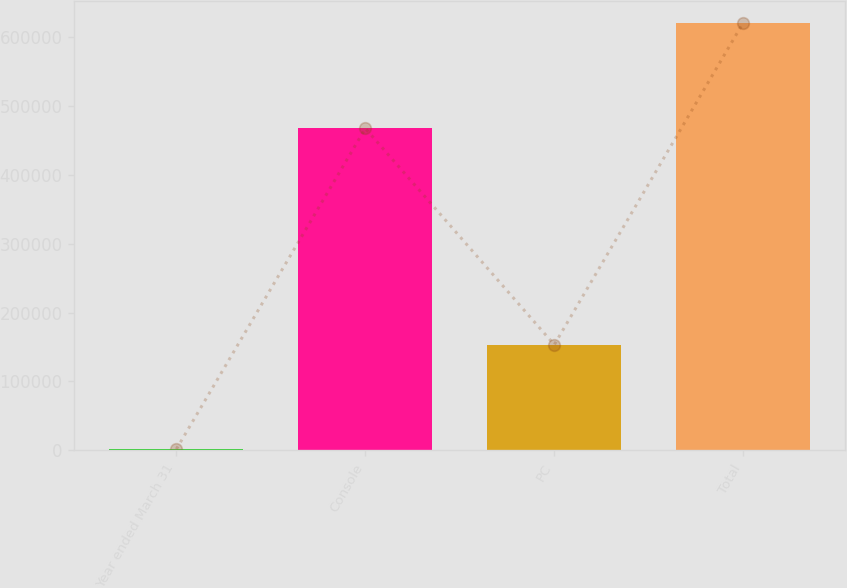Convert chart. <chart><loc_0><loc_0><loc_500><loc_500><bar_chart><fcel>Year ended March 31<fcel>Console<fcel>PC<fcel>Total<nl><fcel>2001<fcel>466893<fcel>153290<fcel>620183<nl></chart> 